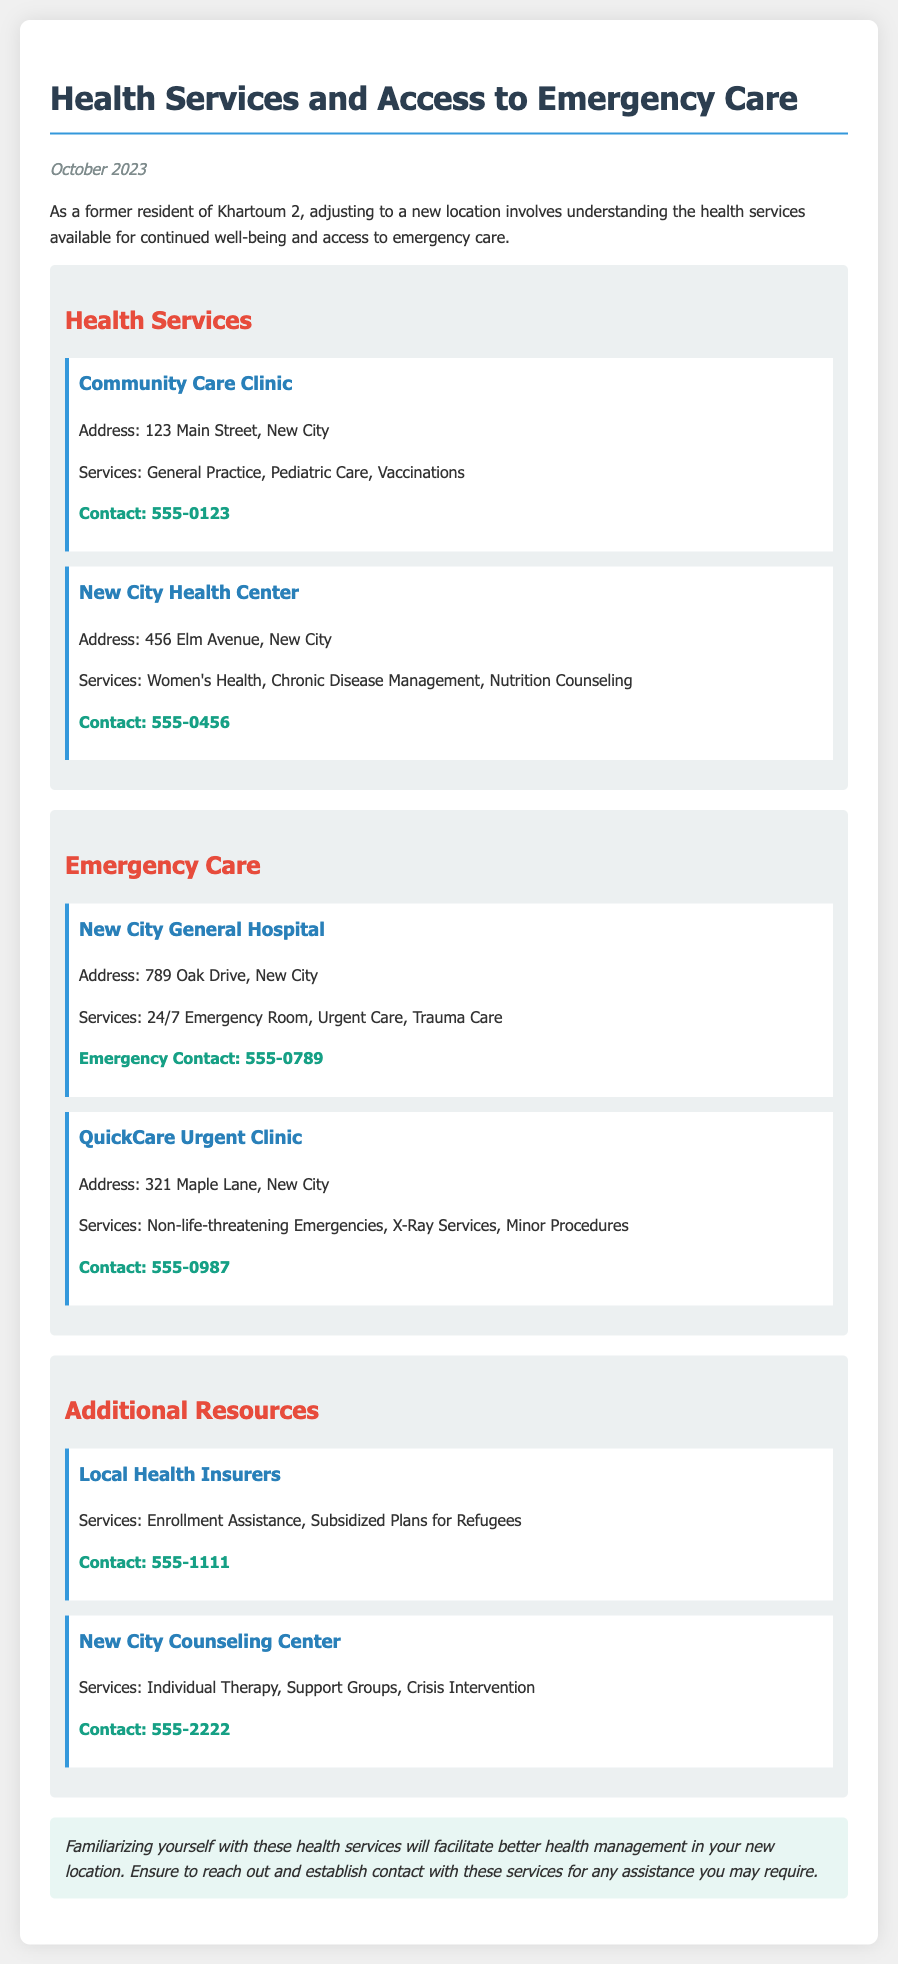What is the address of the Community Care Clinic? The address is found in the section outlining health services, specifically the first clinic listed.
Answer: 123 Main Street, New City What type of services does New City Health Center provide? The types of services offered at this clinic are listed directly under its name in the document.
Answer: Women's Health, Chronic Disease Management, Nutrition Counseling What is the contact number for New City General Hospital? The contact number is provided in the emergency care section for the hospital.
Answer: 555-0789 How many emergency care facilities are mentioned in the document? The document lists two emergency care facilities in the emergency care section.
Answer: 2 What additional resource focuses on crisis intervention? This resource is described as providing various support services, including for crises, in the additional resources section.
Answer: New City Counseling Center What services does QuickCare Urgent Clinic offer? The services offered by QuickCare Urgent Clinic are listed under its name in the emergency care section.
Answer: Non-life-threatening Emergencies, X-Ray Services, Minor Procedures When was the memo published? The date of publication is stated prominently at the top of the document.
Answer: October 2023 Which clinic specializes in pediatric care? The specific clinic offering these services is detailed in the health services section.
Answer: Community Care Clinic 